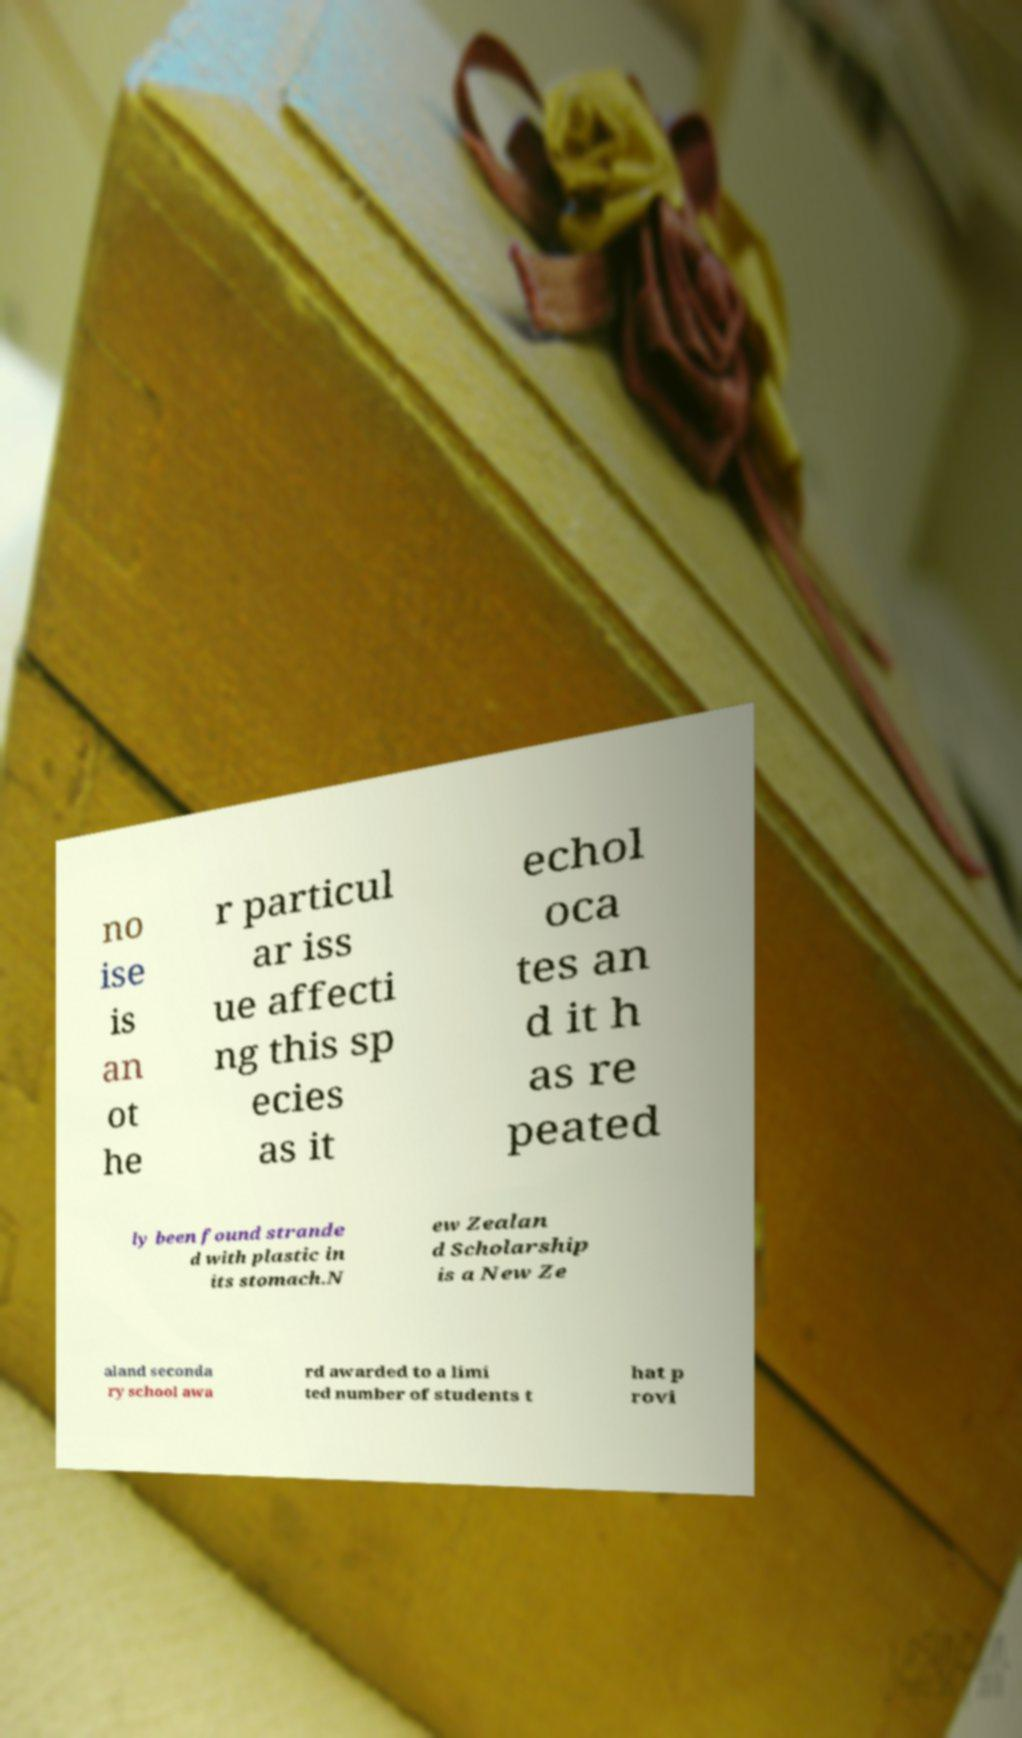Please read and relay the text visible in this image. What does it say? no ise is an ot he r particul ar iss ue affecti ng this sp ecies as it echol oca tes an d it h as re peated ly been found strande d with plastic in its stomach.N ew Zealan d Scholarship is a New Ze aland seconda ry school awa rd awarded to a limi ted number of students t hat p rovi 